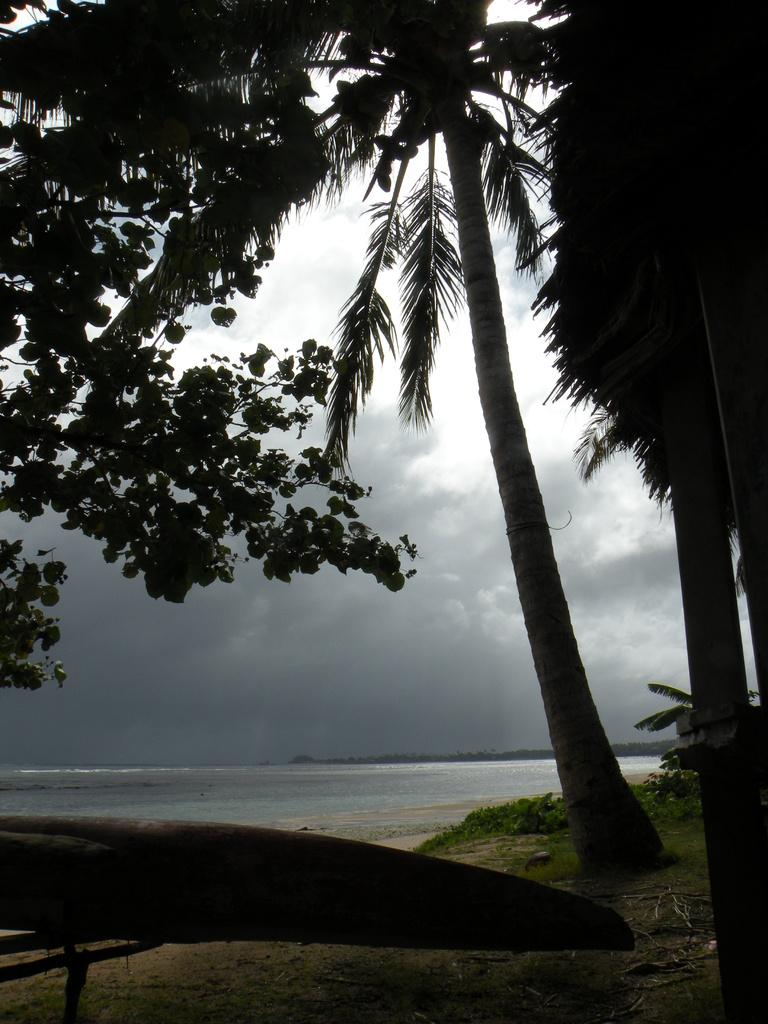What type of trees can be seen in the image? There are coconut trees in the image. Where are the coconut trees located? The coconut trees are on the seaside. What is the primary feature visible in front of the image? The seaside is in front of the image. What can be seen in the background of the image? There is sea water visible in the image. Are there any visible prints on the coconut trees in the image? There are no visible prints on the coconut trees in the image. What type of engine can be seen powering the coconut trees in the image? There is no engine present in the image; the coconut trees are natural plants. 